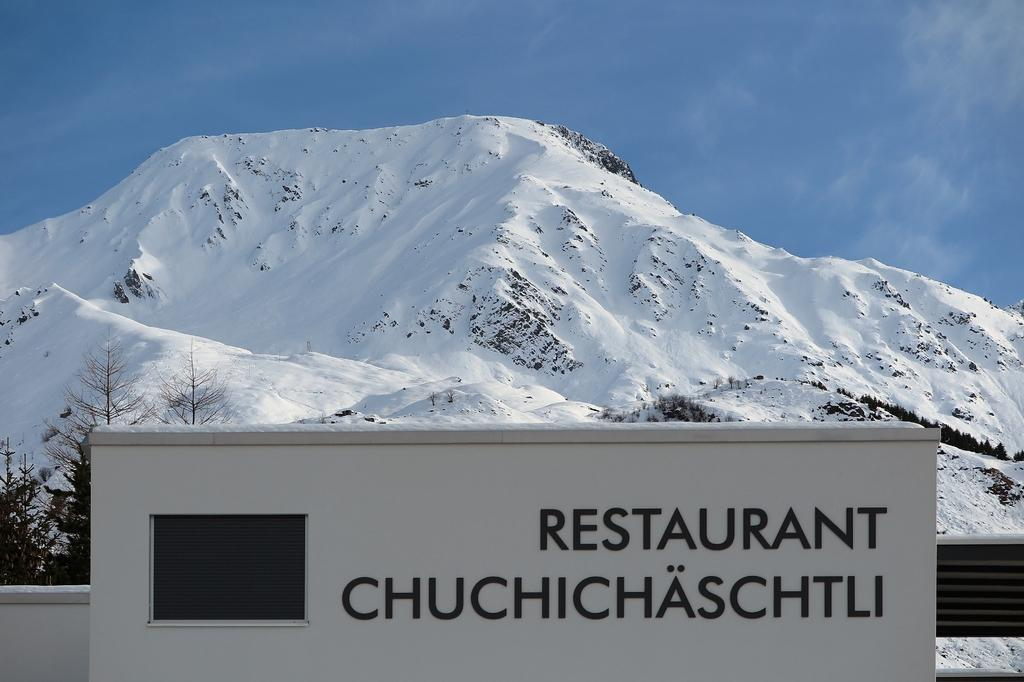<image>
Describe the image concisely. Infront of a snow covered mountain is a sign for a restaurant. 